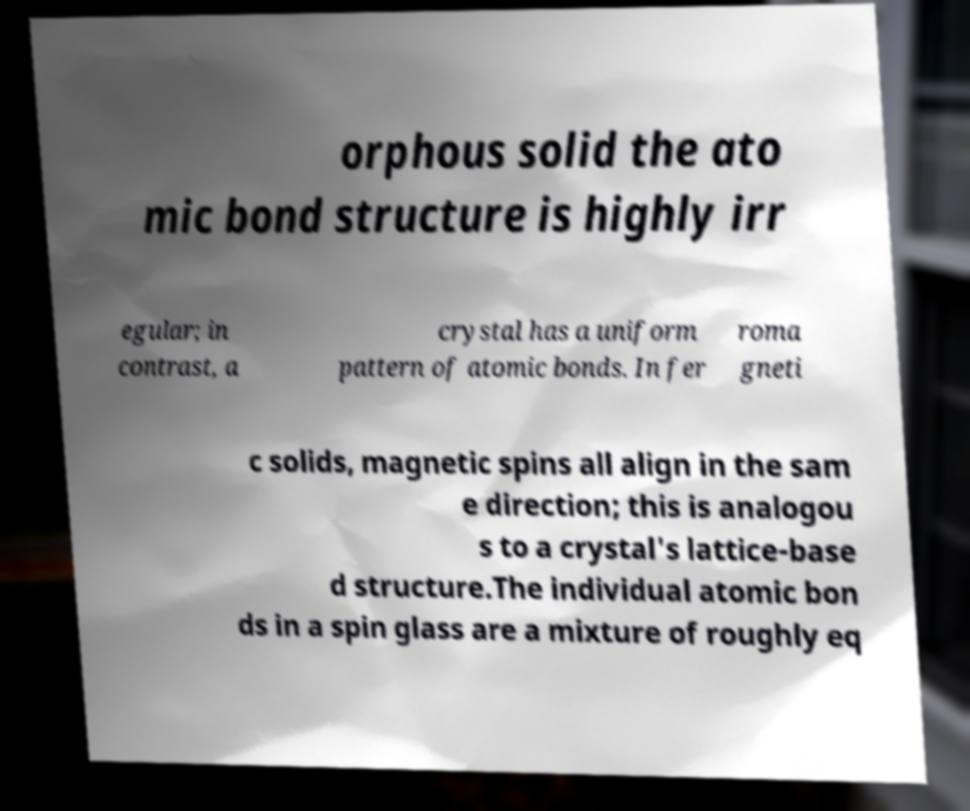Could you extract and type out the text from this image? orphous solid the ato mic bond structure is highly irr egular; in contrast, a crystal has a uniform pattern of atomic bonds. In fer roma gneti c solids, magnetic spins all align in the sam e direction; this is analogou s to a crystal's lattice-base d structure.The individual atomic bon ds in a spin glass are a mixture of roughly eq 